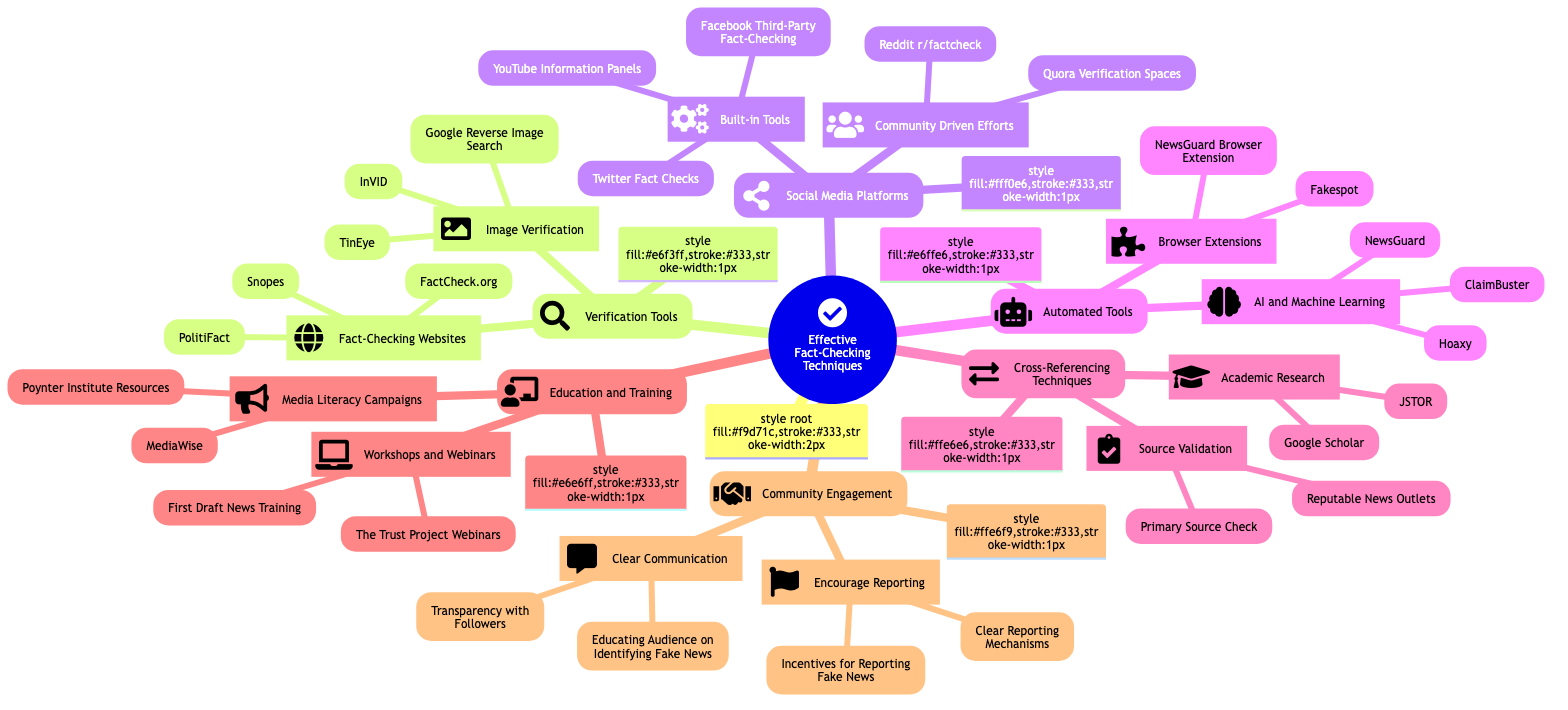What are the two main categories under Verification Tools? The diagram shows "Fact-Checking Websites" and "Image Verification" as the two subcategories under the main category "Verification Tools".
Answer: Fact-Checking Websites, Image Verification How many communities are listed under Community Engagement? In the Community Engagement section, there are two subcategories: "Encourage Reporting" and "Clear Communication", resulting in a total of two communities.
Answer: 2 Which website is listed for AI and Machine Learning tools? The diagram specifies "ClaimBuster", "Hoaxy", and "NewsGuard" under the "AI and Machine Learning" tools subcategory, hence the answer is any one of them.
Answer: ClaimBuster What type of tools fall under the Automated Tools category? The Automated Tools category consists of two subcategories: "AI and Machine Learning" and "Browser Extensions". Therefore, the tools specified show that they include both types under this category.
Answer: AI and Machine Learning, Browser Extensions Which fact-checking resource is associated with academic research? "Google Scholar" and "JSTOR" are both categorized under "Academic Research" in the Cross-Referencing Techniques section of the diagram, thus both are valid answers.
Answer: Google Scholar What is the recommended action under Encourage Reporting? The diagram lists "Incentives for Reporting Fake News" and "Clear Reporting Mechanisms", indicating these are suggested actions categorized under "Encourage Reporting".
Answer: Incentives for Reporting Fake News How many workshops are mentioned under Education and Training? The section of Education and Training contains two entries under the “Workshops and Webinars” subcategory, specifically "First Draft News Training" and "The Trust Project Webinars". Consequently, the total is two workshops.
Answer: 2 What is one of the built-in tools listed for fact-checking on social media platforms? The diagram mentions "Facebook Third-Party Fact-Checking", "Twitter Fact Checks", and "YouTube Information Panels" as built-in tools under social media platforms, so any of these would be a correct answer.
Answer: Facebook Third-Party Fact-Checking Which organization is mentioned as part of Media Literacy Campaigns? In the Education and Training section, "MediaWise" is explicitly mentioned under the "Media Literacy Campaigns" subcategory.
Answer: MediaWise 